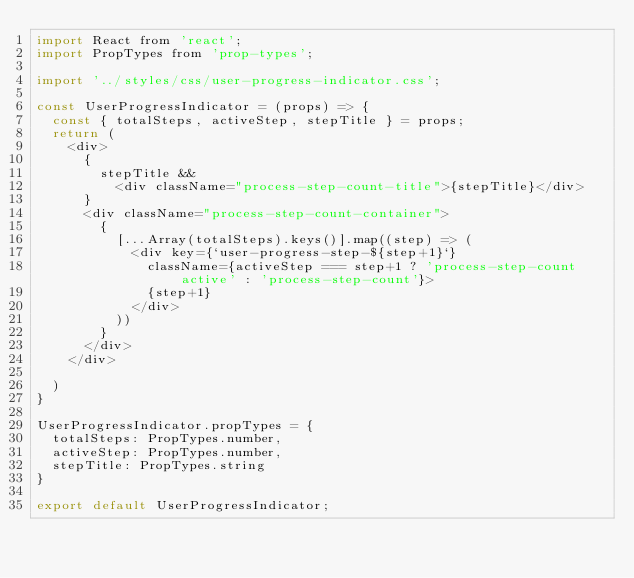Convert code to text. <code><loc_0><loc_0><loc_500><loc_500><_JavaScript_>import React from 'react';
import PropTypes from 'prop-types';

import '../styles/css/user-progress-indicator.css';

const UserProgressIndicator = (props) => {
  const { totalSteps, activeStep, stepTitle } = props;
  return (
    <div>
      {
        stepTitle &&
          <div className="process-step-count-title">{stepTitle}</div>
      }
      <div className="process-step-count-container">
        {
          [...Array(totalSteps).keys()].map((step) => (
            <div key={`user-progress-step-${step+1}`}
              className={activeStep === step+1 ? 'process-step-count active' : 'process-step-count'}>
              {step+1}
            </div>
          ))
        }
      </div>
    </div>

  )
}

UserProgressIndicator.propTypes = {
  totalSteps: PropTypes.number,
  activeStep: PropTypes.number,
  stepTitle: PropTypes.string
}

export default UserProgressIndicator;
</code> 